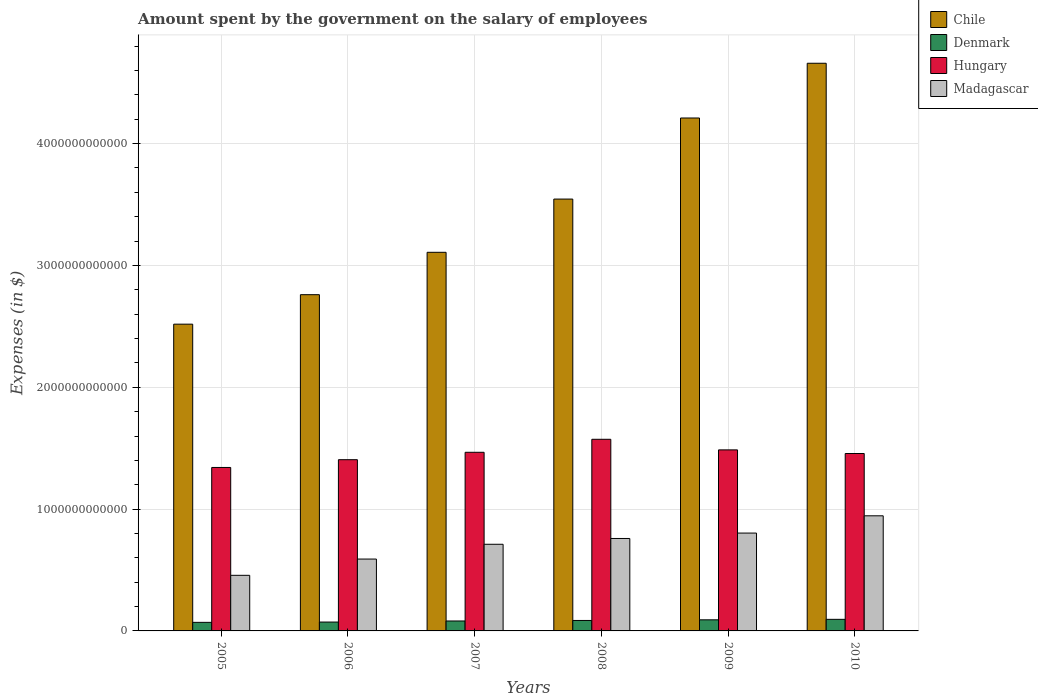How many groups of bars are there?
Give a very brief answer. 6. Are the number of bars per tick equal to the number of legend labels?
Give a very brief answer. Yes. Are the number of bars on each tick of the X-axis equal?
Provide a succinct answer. Yes. What is the label of the 1st group of bars from the left?
Your answer should be very brief. 2005. What is the amount spent on the salary of employees by the government in Denmark in 2006?
Your response must be concise. 7.28e+1. Across all years, what is the maximum amount spent on the salary of employees by the government in Madagascar?
Your answer should be compact. 9.45e+11. Across all years, what is the minimum amount spent on the salary of employees by the government in Hungary?
Provide a succinct answer. 1.34e+12. In which year was the amount spent on the salary of employees by the government in Chile maximum?
Offer a terse response. 2010. What is the total amount spent on the salary of employees by the government in Chile in the graph?
Provide a short and direct response. 2.08e+13. What is the difference between the amount spent on the salary of employees by the government in Chile in 2006 and that in 2007?
Make the answer very short. -3.48e+11. What is the difference between the amount spent on the salary of employees by the government in Denmark in 2007 and the amount spent on the salary of employees by the government in Madagascar in 2009?
Ensure brevity in your answer.  -7.22e+11. What is the average amount spent on the salary of employees by the government in Chile per year?
Provide a succinct answer. 3.47e+12. In the year 2007, what is the difference between the amount spent on the salary of employees by the government in Madagascar and amount spent on the salary of employees by the government in Chile?
Give a very brief answer. -2.40e+12. In how many years, is the amount spent on the salary of employees by the government in Madagascar greater than 4200000000000 $?
Your answer should be compact. 0. What is the ratio of the amount spent on the salary of employees by the government in Madagascar in 2005 to that in 2007?
Make the answer very short. 0.64. Is the amount spent on the salary of employees by the government in Denmark in 2005 less than that in 2008?
Your answer should be compact. Yes. Is the difference between the amount spent on the salary of employees by the government in Madagascar in 2005 and 2006 greater than the difference between the amount spent on the salary of employees by the government in Chile in 2005 and 2006?
Provide a short and direct response. Yes. What is the difference between the highest and the second highest amount spent on the salary of employees by the government in Denmark?
Offer a terse response. 4.02e+09. What is the difference between the highest and the lowest amount spent on the salary of employees by the government in Madagascar?
Your answer should be very brief. 4.89e+11. In how many years, is the amount spent on the salary of employees by the government in Denmark greater than the average amount spent on the salary of employees by the government in Denmark taken over all years?
Give a very brief answer. 3. Is it the case that in every year, the sum of the amount spent on the salary of employees by the government in Madagascar and amount spent on the salary of employees by the government in Hungary is greater than the sum of amount spent on the salary of employees by the government in Denmark and amount spent on the salary of employees by the government in Chile?
Your answer should be very brief. No. What does the 4th bar from the left in 2006 represents?
Provide a short and direct response. Madagascar. How many years are there in the graph?
Offer a terse response. 6. What is the difference between two consecutive major ticks on the Y-axis?
Your answer should be compact. 1.00e+12. Are the values on the major ticks of Y-axis written in scientific E-notation?
Offer a terse response. No. Does the graph contain grids?
Your response must be concise. Yes. Where does the legend appear in the graph?
Your response must be concise. Top right. What is the title of the graph?
Your answer should be compact. Amount spent by the government on the salary of employees. What is the label or title of the Y-axis?
Make the answer very short. Expenses (in $). What is the Expenses (in $) in Chile in 2005?
Offer a very short reply. 2.52e+12. What is the Expenses (in $) of Denmark in 2005?
Provide a short and direct response. 7.03e+1. What is the Expenses (in $) in Hungary in 2005?
Your answer should be very brief. 1.34e+12. What is the Expenses (in $) of Madagascar in 2005?
Make the answer very short. 4.56e+11. What is the Expenses (in $) of Chile in 2006?
Ensure brevity in your answer.  2.76e+12. What is the Expenses (in $) of Denmark in 2006?
Offer a terse response. 7.28e+1. What is the Expenses (in $) of Hungary in 2006?
Give a very brief answer. 1.41e+12. What is the Expenses (in $) in Madagascar in 2006?
Ensure brevity in your answer.  5.90e+11. What is the Expenses (in $) of Chile in 2007?
Offer a very short reply. 3.11e+12. What is the Expenses (in $) of Denmark in 2007?
Keep it short and to the point. 8.16e+1. What is the Expenses (in $) in Hungary in 2007?
Ensure brevity in your answer.  1.47e+12. What is the Expenses (in $) of Madagascar in 2007?
Provide a succinct answer. 7.11e+11. What is the Expenses (in $) of Chile in 2008?
Provide a short and direct response. 3.54e+12. What is the Expenses (in $) in Denmark in 2008?
Ensure brevity in your answer.  8.58e+1. What is the Expenses (in $) in Hungary in 2008?
Your response must be concise. 1.57e+12. What is the Expenses (in $) in Madagascar in 2008?
Your answer should be very brief. 7.59e+11. What is the Expenses (in $) in Chile in 2009?
Offer a very short reply. 4.21e+12. What is the Expenses (in $) in Denmark in 2009?
Offer a terse response. 9.11e+1. What is the Expenses (in $) in Hungary in 2009?
Your answer should be very brief. 1.49e+12. What is the Expenses (in $) in Madagascar in 2009?
Your answer should be very brief. 8.03e+11. What is the Expenses (in $) of Chile in 2010?
Your response must be concise. 4.66e+12. What is the Expenses (in $) in Denmark in 2010?
Your response must be concise. 9.51e+1. What is the Expenses (in $) of Hungary in 2010?
Offer a very short reply. 1.46e+12. What is the Expenses (in $) in Madagascar in 2010?
Make the answer very short. 9.45e+11. Across all years, what is the maximum Expenses (in $) of Chile?
Your answer should be compact. 4.66e+12. Across all years, what is the maximum Expenses (in $) in Denmark?
Keep it short and to the point. 9.51e+1. Across all years, what is the maximum Expenses (in $) in Hungary?
Provide a succinct answer. 1.57e+12. Across all years, what is the maximum Expenses (in $) of Madagascar?
Your answer should be very brief. 9.45e+11. Across all years, what is the minimum Expenses (in $) of Chile?
Your answer should be compact. 2.52e+12. Across all years, what is the minimum Expenses (in $) in Denmark?
Offer a very short reply. 7.03e+1. Across all years, what is the minimum Expenses (in $) of Hungary?
Provide a succinct answer. 1.34e+12. Across all years, what is the minimum Expenses (in $) of Madagascar?
Offer a very short reply. 4.56e+11. What is the total Expenses (in $) in Chile in the graph?
Provide a short and direct response. 2.08e+13. What is the total Expenses (in $) of Denmark in the graph?
Make the answer very short. 4.97e+11. What is the total Expenses (in $) of Hungary in the graph?
Provide a short and direct response. 8.73e+12. What is the total Expenses (in $) of Madagascar in the graph?
Your answer should be very brief. 4.26e+12. What is the difference between the Expenses (in $) in Chile in 2005 and that in 2006?
Offer a terse response. -2.42e+11. What is the difference between the Expenses (in $) in Denmark in 2005 and that in 2006?
Provide a succinct answer. -2.54e+09. What is the difference between the Expenses (in $) of Hungary in 2005 and that in 2006?
Your response must be concise. -6.37e+1. What is the difference between the Expenses (in $) of Madagascar in 2005 and that in 2006?
Provide a succinct answer. -1.34e+11. What is the difference between the Expenses (in $) of Chile in 2005 and that in 2007?
Give a very brief answer. -5.90e+11. What is the difference between the Expenses (in $) in Denmark in 2005 and that in 2007?
Offer a very short reply. -1.13e+1. What is the difference between the Expenses (in $) in Hungary in 2005 and that in 2007?
Keep it short and to the point. -1.25e+11. What is the difference between the Expenses (in $) in Madagascar in 2005 and that in 2007?
Give a very brief answer. -2.55e+11. What is the difference between the Expenses (in $) in Chile in 2005 and that in 2008?
Your answer should be very brief. -1.03e+12. What is the difference between the Expenses (in $) in Denmark in 2005 and that in 2008?
Give a very brief answer. -1.55e+1. What is the difference between the Expenses (in $) in Hungary in 2005 and that in 2008?
Your answer should be compact. -2.31e+11. What is the difference between the Expenses (in $) of Madagascar in 2005 and that in 2008?
Your answer should be very brief. -3.02e+11. What is the difference between the Expenses (in $) of Chile in 2005 and that in 2009?
Offer a terse response. -1.69e+12. What is the difference between the Expenses (in $) in Denmark in 2005 and that in 2009?
Your answer should be compact. -2.08e+1. What is the difference between the Expenses (in $) in Hungary in 2005 and that in 2009?
Your answer should be very brief. -1.44e+11. What is the difference between the Expenses (in $) in Madagascar in 2005 and that in 2009?
Ensure brevity in your answer.  -3.47e+11. What is the difference between the Expenses (in $) in Chile in 2005 and that in 2010?
Your answer should be compact. -2.14e+12. What is the difference between the Expenses (in $) in Denmark in 2005 and that in 2010?
Keep it short and to the point. -2.48e+1. What is the difference between the Expenses (in $) of Hungary in 2005 and that in 2010?
Your answer should be compact. -1.15e+11. What is the difference between the Expenses (in $) of Madagascar in 2005 and that in 2010?
Give a very brief answer. -4.89e+11. What is the difference between the Expenses (in $) in Chile in 2006 and that in 2007?
Provide a short and direct response. -3.48e+11. What is the difference between the Expenses (in $) of Denmark in 2006 and that in 2007?
Give a very brief answer. -8.81e+09. What is the difference between the Expenses (in $) of Hungary in 2006 and that in 2007?
Ensure brevity in your answer.  -6.08e+1. What is the difference between the Expenses (in $) of Madagascar in 2006 and that in 2007?
Provide a succinct answer. -1.21e+11. What is the difference between the Expenses (in $) of Chile in 2006 and that in 2008?
Your response must be concise. -7.85e+11. What is the difference between the Expenses (in $) in Denmark in 2006 and that in 2008?
Provide a succinct answer. -1.30e+1. What is the difference between the Expenses (in $) of Hungary in 2006 and that in 2008?
Provide a short and direct response. -1.68e+11. What is the difference between the Expenses (in $) in Madagascar in 2006 and that in 2008?
Provide a succinct answer. -1.69e+11. What is the difference between the Expenses (in $) of Chile in 2006 and that in 2009?
Ensure brevity in your answer.  -1.45e+12. What is the difference between the Expenses (in $) of Denmark in 2006 and that in 2009?
Keep it short and to the point. -1.83e+1. What is the difference between the Expenses (in $) in Hungary in 2006 and that in 2009?
Your answer should be very brief. -8.06e+1. What is the difference between the Expenses (in $) of Madagascar in 2006 and that in 2009?
Your answer should be very brief. -2.13e+11. What is the difference between the Expenses (in $) in Chile in 2006 and that in 2010?
Ensure brevity in your answer.  -1.90e+12. What is the difference between the Expenses (in $) of Denmark in 2006 and that in 2010?
Offer a very short reply. -2.23e+1. What is the difference between the Expenses (in $) of Hungary in 2006 and that in 2010?
Give a very brief answer. -5.09e+1. What is the difference between the Expenses (in $) in Madagascar in 2006 and that in 2010?
Offer a terse response. -3.55e+11. What is the difference between the Expenses (in $) in Chile in 2007 and that in 2008?
Give a very brief answer. -4.37e+11. What is the difference between the Expenses (in $) in Denmark in 2007 and that in 2008?
Offer a terse response. -4.16e+09. What is the difference between the Expenses (in $) in Hungary in 2007 and that in 2008?
Keep it short and to the point. -1.07e+11. What is the difference between the Expenses (in $) in Madagascar in 2007 and that in 2008?
Provide a succinct answer. -4.77e+1. What is the difference between the Expenses (in $) in Chile in 2007 and that in 2009?
Your answer should be very brief. -1.10e+12. What is the difference between the Expenses (in $) in Denmark in 2007 and that in 2009?
Offer a very short reply. -9.48e+09. What is the difference between the Expenses (in $) in Hungary in 2007 and that in 2009?
Offer a terse response. -1.98e+1. What is the difference between the Expenses (in $) of Madagascar in 2007 and that in 2009?
Provide a short and direct response. -9.20e+1. What is the difference between the Expenses (in $) in Chile in 2007 and that in 2010?
Provide a succinct answer. -1.55e+12. What is the difference between the Expenses (in $) in Denmark in 2007 and that in 2010?
Ensure brevity in your answer.  -1.35e+1. What is the difference between the Expenses (in $) in Hungary in 2007 and that in 2010?
Ensure brevity in your answer.  9.96e+09. What is the difference between the Expenses (in $) in Madagascar in 2007 and that in 2010?
Ensure brevity in your answer.  -2.34e+11. What is the difference between the Expenses (in $) of Chile in 2008 and that in 2009?
Your response must be concise. -6.66e+11. What is the difference between the Expenses (in $) of Denmark in 2008 and that in 2009?
Your answer should be compact. -5.31e+09. What is the difference between the Expenses (in $) of Hungary in 2008 and that in 2009?
Your answer should be compact. 8.70e+1. What is the difference between the Expenses (in $) in Madagascar in 2008 and that in 2009?
Keep it short and to the point. -4.43e+1. What is the difference between the Expenses (in $) in Chile in 2008 and that in 2010?
Offer a very short reply. -1.11e+12. What is the difference between the Expenses (in $) in Denmark in 2008 and that in 2010?
Your answer should be very brief. -9.33e+09. What is the difference between the Expenses (in $) in Hungary in 2008 and that in 2010?
Make the answer very short. 1.17e+11. What is the difference between the Expenses (in $) of Madagascar in 2008 and that in 2010?
Offer a terse response. -1.86e+11. What is the difference between the Expenses (in $) of Chile in 2009 and that in 2010?
Your answer should be compact. -4.49e+11. What is the difference between the Expenses (in $) of Denmark in 2009 and that in 2010?
Keep it short and to the point. -4.02e+09. What is the difference between the Expenses (in $) in Hungary in 2009 and that in 2010?
Your response must be concise. 2.97e+1. What is the difference between the Expenses (in $) in Madagascar in 2009 and that in 2010?
Make the answer very short. -1.42e+11. What is the difference between the Expenses (in $) in Chile in 2005 and the Expenses (in $) in Denmark in 2006?
Keep it short and to the point. 2.45e+12. What is the difference between the Expenses (in $) in Chile in 2005 and the Expenses (in $) in Hungary in 2006?
Provide a short and direct response. 1.11e+12. What is the difference between the Expenses (in $) of Chile in 2005 and the Expenses (in $) of Madagascar in 2006?
Your answer should be compact. 1.93e+12. What is the difference between the Expenses (in $) in Denmark in 2005 and the Expenses (in $) in Hungary in 2006?
Give a very brief answer. -1.34e+12. What is the difference between the Expenses (in $) in Denmark in 2005 and the Expenses (in $) in Madagascar in 2006?
Keep it short and to the point. -5.20e+11. What is the difference between the Expenses (in $) in Hungary in 2005 and the Expenses (in $) in Madagascar in 2006?
Make the answer very short. 7.52e+11. What is the difference between the Expenses (in $) in Chile in 2005 and the Expenses (in $) in Denmark in 2007?
Your answer should be compact. 2.44e+12. What is the difference between the Expenses (in $) of Chile in 2005 and the Expenses (in $) of Hungary in 2007?
Provide a succinct answer. 1.05e+12. What is the difference between the Expenses (in $) of Chile in 2005 and the Expenses (in $) of Madagascar in 2007?
Offer a very short reply. 1.81e+12. What is the difference between the Expenses (in $) in Denmark in 2005 and the Expenses (in $) in Hungary in 2007?
Your answer should be compact. -1.40e+12. What is the difference between the Expenses (in $) in Denmark in 2005 and the Expenses (in $) in Madagascar in 2007?
Ensure brevity in your answer.  -6.41e+11. What is the difference between the Expenses (in $) of Hungary in 2005 and the Expenses (in $) of Madagascar in 2007?
Your answer should be very brief. 6.31e+11. What is the difference between the Expenses (in $) of Chile in 2005 and the Expenses (in $) of Denmark in 2008?
Provide a succinct answer. 2.43e+12. What is the difference between the Expenses (in $) in Chile in 2005 and the Expenses (in $) in Hungary in 2008?
Your response must be concise. 9.45e+11. What is the difference between the Expenses (in $) in Chile in 2005 and the Expenses (in $) in Madagascar in 2008?
Your response must be concise. 1.76e+12. What is the difference between the Expenses (in $) in Denmark in 2005 and the Expenses (in $) in Hungary in 2008?
Provide a succinct answer. -1.50e+12. What is the difference between the Expenses (in $) in Denmark in 2005 and the Expenses (in $) in Madagascar in 2008?
Provide a short and direct response. -6.89e+11. What is the difference between the Expenses (in $) in Hungary in 2005 and the Expenses (in $) in Madagascar in 2008?
Offer a very short reply. 5.83e+11. What is the difference between the Expenses (in $) in Chile in 2005 and the Expenses (in $) in Denmark in 2009?
Provide a short and direct response. 2.43e+12. What is the difference between the Expenses (in $) of Chile in 2005 and the Expenses (in $) of Hungary in 2009?
Offer a terse response. 1.03e+12. What is the difference between the Expenses (in $) in Chile in 2005 and the Expenses (in $) in Madagascar in 2009?
Ensure brevity in your answer.  1.71e+12. What is the difference between the Expenses (in $) of Denmark in 2005 and the Expenses (in $) of Hungary in 2009?
Ensure brevity in your answer.  -1.42e+12. What is the difference between the Expenses (in $) of Denmark in 2005 and the Expenses (in $) of Madagascar in 2009?
Your answer should be compact. -7.33e+11. What is the difference between the Expenses (in $) in Hungary in 2005 and the Expenses (in $) in Madagascar in 2009?
Provide a short and direct response. 5.39e+11. What is the difference between the Expenses (in $) in Chile in 2005 and the Expenses (in $) in Denmark in 2010?
Keep it short and to the point. 2.42e+12. What is the difference between the Expenses (in $) of Chile in 2005 and the Expenses (in $) of Hungary in 2010?
Provide a short and direct response. 1.06e+12. What is the difference between the Expenses (in $) of Chile in 2005 and the Expenses (in $) of Madagascar in 2010?
Provide a succinct answer. 1.57e+12. What is the difference between the Expenses (in $) in Denmark in 2005 and the Expenses (in $) in Hungary in 2010?
Your answer should be very brief. -1.39e+12. What is the difference between the Expenses (in $) in Denmark in 2005 and the Expenses (in $) in Madagascar in 2010?
Provide a succinct answer. -8.75e+11. What is the difference between the Expenses (in $) in Hungary in 2005 and the Expenses (in $) in Madagascar in 2010?
Your answer should be very brief. 3.97e+11. What is the difference between the Expenses (in $) of Chile in 2006 and the Expenses (in $) of Denmark in 2007?
Your answer should be compact. 2.68e+12. What is the difference between the Expenses (in $) in Chile in 2006 and the Expenses (in $) in Hungary in 2007?
Your answer should be very brief. 1.29e+12. What is the difference between the Expenses (in $) of Chile in 2006 and the Expenses (in $) of Madagascar in 2007?
Your response must be concise. 2.05e+12. What is the difference between the Expenses (in $) of Denmark in 2006 and the Expenses (in $) of Hungary in 2007?
Give a very brief answer. -1.39e+12. What is the difference between the Expenses (in $) in Denmark in 2006 and the Expenses (in $) in Madagascar in 2007?
Your answer should be compact. -6.38e+11. What is the difference between the Expenses (in $) in Hungary in 2006 and the Expenses (in $) in Madagascar in 2007?
Your answer should be compact. 6.94e+11. What is the difference between the Expenses (in $) in Chile in 2006 and the Expenses (in $) in Denmark in 2008?
Offer a very short reply. 2.67e+12. What is the difference between the Expenses (in $) of Chile in 2006 and the Expenses (in $) of Hungary in 2008?
Make the answer very short. 1.19e+12. What is the difference between the Expenses (in $) in Chile in 2006 and the Expenses (in $) in Madagascar in 2008?
Give a very brief answer. 2.00e+12. What is the difference between the Expenses (in $) in Denmark in 2006 and the Expenses (in $) in Hungary in 2008?
Give a very brief answer. -1.50e+12. What is the difference between the Expenses (in $) in Denmark in 2006 and the Expenses (in $) in Madagascar in 2008?
Offer a terse response. -6.86e+11. What is the difference between the Expenses (in $) of Hungary in 2006 and the Expenses (in $) of Madagascar in 2008?
Your answer should be compact. 6.47e+11. What is the difference between the Expenses (in $) of Chile in 2006 and the Expenses (in $) of Denmark in 2009?
Offer a very short reply. 2.67e+12. What is the difference between the Expenses (in $) in Chile in 2006 and the Expenses (in $) in Hungary in 2009?
Offer a terse response. 1.27e+12. What is the difference between the Expenses (in $) in Chile in 2006 and the Expenses (in $) in Madagascar in 2009?
Offer a terse response. 1.96e+12. What is the difference between the Expenses (in $) of Denmark in 2006 and the Expenses (in $) of Hungary in 2009?
Provide a short and direct response. -1.41e+12. What is the difference between the Expenses (in $) of Denmark in 2006 and the Expenses (in $) of Madagascar in 2009?
Your answer should be compact. -7.30e+11. What is the difference between the Expenses (in $) of Hungary in 2006 and the Expenses (in $) of Madagascar in 2009?
Your response must be concise. 6.02e+11. What is the difference between the Expenses (in $) of Chile in 2006 and the Expenses (in $) of Denmark in 2010?
Give a very brief answer. 2.66e+12. What is the difference between the Expenses (in $) of Chile in 2006 and the Expenses (in $) of Hungary in 2010?
Ensure brevity in your answer.  1.30e+12. What is the difference between the Expenses (in $) in Chile in 2006 and the Expenses (in $) in Madagascar in 2010?
Your answer should be very brief. 1.82e+12. What is the difference between the Expenses (in $) of Denmark in 2006 and the Expenses (in $) of Hungary in 2010?
Provide a short and direct response. -1.38e+12. What is the difference between the Expenses (in $) in Denmark in 2006 and the Expenses (in $) in Madagascar in 2010?
Your answer should be compact. -8.72e+11. What is the difference between the Expenses (in $) of Hungary in 2006 and the Expenses (in $) of Madagascar in 2010?
Ensure brevity in your answer.  4.61e+11. What is the difference between the Expenses (in $) of Chile in 2007 and the Expenses (in $) of Denmark in 2008?
Your response must be concise. 3.02e+12. What is the difference between the Expenses (in $) in Chile in 2007 and the Expenses (in $) in Hungary in 2008?
Ensure brevity in your answer.  1.53e+12. What is the difference between the Expenses (in $) of Chile in 2007 and the Expenses (in $) of Madagascar in 2008?
Provide a succinct answer. 2.35e+12. What is the difference between the Expenses (in $) in Denmark in 2007 and the Expenses (in $) in Hungary in 2008?
Your answer should be very brief. -1.49e+12. What is the difference between the Expenses (in $) of Denmark in 2007 and the Expenses (in $) of Madagascar in 2008?
Provide a succinct answer. -6.77e+11. What is the difference between the Expenses (in $) of Hungary in 2007 and the Expenses (in $) of Madagascar in 2008?
Keep it short and to the point. 7.07e+11. What is the difference between the Expenses (in $) of Chile in 2007 and the Expenses (in $) of Denmark in 2009?
Provide a succinct answer. 3.02e+12. What is the difference between the Expenses (in $) in Chile in 2007 and the Expenses (in $) in Hungary in 2009?
Ensure brevity in your answer.  1.62e+12. What is the difference between the Expenses (in $) in Chile in 2007 and the Expenses (in $) in Madagascar in 2009?
Keep it short and to the point. 2.30e+12. What is the difference between the Expenses (in $) of Denmark in 2007 and the Expenses (in $) of Hungary in 2009?
Your answer should be compact. -1.40e+12. What is the difference between the Expenses (in $) of Denmark in 2007 and the Expenses (in $) of Madagascar in 2009?
Provide a short and direct response. -7.22e+11. What is the difference between the Expenses (in $) of Hungary in 2007 and the Expenses (in $) of Madagascar in 2009?
Ensure brevity in your answer.  6.63e+11. What is the difference between the Expenses (in $) of Chile in 2007 and the Expenses (in $) of Denmark in 2010?
Give a very brief answer. 3.01e+12. What is the difference between the Expenses (in $) of Chile in 2007 and the Expenses (in $) of Hungary in 2010?
Your answer should be very brief. 1.65e+12. What is the difference between the Expenses (in $) of Chile in 2007 and the Expenses (in $) of Madagascar in 2010?
Offer a terse response. 2.16e+12. What is the difference between the Expenses (in $) in Denmark in 2007 and the Expenses (in $) in Hungary in 2010?
Offer a very short reply. -1.37e+12. What is the difference between the Expenses (in $) in Denmark in 2007 and the Expenses (in $) in Madagascar in 2010?
Ensure brevity in your answer.  -8.63e+11. What is the difference between the Expenses (in $) of Hungary in 2007 and the Expenses (in $) of Madagascar in 2010?
Ensure brevity in your answer.  5.21e+11. What is the difference between the Expenses (in $) in Chile in 2008 and the Expenses (in $) in Denmark in 2009?
Offer a very short reply. 3.45e+12. What is the difference between the Expenses (in $) in Chile in 2008 and the Expenses (in $) in Hungary in 2009?
Your answer should be compact. 2.06e+12. What is the difference between the Expenses (in $) in Chile in 2008 and the Expenses (in $) in Madagascar in 2009?
Your response must be concise. 2.74e+12. What is the difference between the Expenses (in $) of Denmark in 2008 and the Expenses (in $) of Hungary in 2009?
Make the answer very short. -1.40e+12. What is the difference between the Expenses (in $) of Denmark in 2008 and the Expenses (in $) of Madagascar in 2009?
Give a very brief answer. -7.17e+11. What is the difference between the Expenses (in $) of Hungary in 2008 and the Expenses (in $) of Madagascar in 2009?
Make the answer very short. 7.70e+11. What is the difference between the Expenses (in $) in Chile in 2008 and the Expenses (in $) in Denmark in 2010?
Make the answer very short. 3.45e+12. What is the difference between the Expenses (in $) in Chile in 2008 and the Expenses (in $) in Hungary in 2010?
Provide a succinct answer. 2.09e+12. What is the difference between the Expenses (in $) in Chile in 2008 and the Expenses (in $) in Madagascar in 2010?
Offer a very short reply. 2.60e+12. What is the difference between the Expenses (in $) in Denmark in 2008 and the Expenses (in $) in Hungary in 2010?
Keep it short and to the point. -1.37e+12. What is the difference between the Expenses (in $) in Denmark in 2008 and the Expenses (in $) in Madagascar in 2010?
Your answer should be very brief. -8.59e+11. What is the difference between the Expenses (in $) of Hungary in 2008 and the Expenses (in $) of Madagascar in 2010?
Your answer should be very brief. 6.28e+11. What is the difference between the Expenses (in $) in Chile in 2009 and the Expenses (in $) in Denmark in 2010?
Give a very brief answer. 4.12e+12. What is the difference between the Expenses (in $) in Chile in 2009 and the Expenses (in $) in Hungary in 2010?
Your response must be concise. 2.75e+12. What is the difference between the Expenses (in $) in Chile in 2009 and the Expenses (in $) in Madagascar in 2010?
Offer a terse response. 3.27e+12. What is the difference between the Expenses (in $) of Denmark in 2009 and the Expenses (in $) of Hungary in 2010?
Offer a very short reply. -1.37e+12. What is the difference between the Expenses (in $) of Denmark in 2009 and the Expenses (in $) of Madagascar in 2010?
Your answer should be very brief. -8.54e+11. What is the difference between the Expenses (in $) of Hungary in 2009 and the Expenses (in $) of Madagascar in 2010?
Make the answer very short. 5.41e+11. What is the average Expenses (in $) of Chile per year?
Provide a succinct answer. 3.47e+12. What is the average Expenses (in $) of Denmark per year?
Provide a succinct answer. 8.28e+1. What is the average Expenses (in $) of Hungary per year?
Your response must be concise. 1.45e+12. What is the average Expenses (in $) of Madagascar per year?
Offer a terse response. 7.11e+11. In the year 2005, what is the difference between the Expenses (in $) of Chile and Expenses (in $) of Denmark?
Provide a short and direct response. 2.45e+12. In the year 2005, what is the difference between the Expenses (in $) of Chile and Expenses (in $) of Hungary?
Offer a terse response. 1.18e+12. In the year 2005, what is the difference between the Expenses (in $) in Chile and Expenses (in $) in Madagascar?
Provide a short and direct response. 2.06e+12. In the year 2005, what is the difference between the Expenses (in $) in Denmark and Expenses (in $) in Hungary?
Make the answer very short. -1.27e+12. In the year 2005, what is the difference between the Expenses (in $) of Denmark and Expenses (in $) of Madagascar?
Make the answer very short. -3.86e+11. In the year 2005, what is the difference between the Expenses (in $) of Hungary and Expenses (in $) of Madagascar?
Your response must be concise. 8.85e+11. In the year 2006, what is the difference between the Expenses (in $) of Chile and Expenses (in $) of Denmark?
Provide a short and direct response. 2.69e+12. In the year 2006, what is the difference between the Expenses (in $) of Chile and Expenses (in $) of Hungary?
Keep it short and to the point. 1.35e+12. In the year 2006, what is the difference between the Expenses (in $) of Chile and Expenses (in $) of Madagascar?
Provide a short and direct response. 2.17e+12. In the year 2006, what is the difference between the Expenses (in $) of Denmark and Expenses (in $) of Hungary?
Offer a very short reply. -1.33e+12. In the year 2006, what is the difference between the Expenses (in $) of Denmark and Expenses (in $) of Madagascar?
Provide a succinct answer. -5.17e+11. In the year 2006, what is the difference between the Expenses (in $) of Hungary and Expenses (in $) of Madagascar?
Your answer should be compact. 8.16e+11. In the year 2007, what is the difference between the Expenses (in $) of Chile and Expenses (in $) of Denmark?
Your answer should be very brief. 3.03e+12. In the year 2007, what is the difference between the Expenses (in $) of Chile and Expenses (in $) of Hungary?
Your answer should be very brief. 1.64e+12. In the year 2007, what is the difference between the Expenses (in $) of Chile and Expenses (in $) of Madagascar?
Offer a terse response. 2.40e+12. In the year 2007, what is the difference between the Expenses (in $) in Denmark and Expenses (in $) in Hungary?
Provide a succinct answer. -1.38e+12. In the year 2007, what is the difference between the Expenses (in $) of Denmark and Expenses (in $) of Madagascar?
Keep it short and to the point. -6.30e+11. In the year 2007, what is the difference between the Expenses (in $) in Hungary and Expenses (in $) in Madagascar?
Your response must be concise. 7.55e+11. In the year 2008, what is the difference between the Expenses (in $) of Chile and Expenses (in $) of Denmark?
Keep it short and to the point. 3.46e+12. In the year 2008, what is the difference between the Expenses (in $) in Chile and Expenses (in $) in Hungary?
Offer a very short reply. 1.97e+12. In the year 2008, what is the difference between the Expenses (in $) in Chile and Expenses (in $) in Madagascar?
Make the answer very short. 2.79e+12. In the year 2008, what is the difference between the Expenses (in $) in Denmark and Expenses (in $) in Hungary?
Keep it short and to the point. -1.49e+12. In the year 2008, what is the difference between the Expenses (in $) in Denmark and Expenses (in $) in Madagascar?
Offer a terse response. -6.73e+11. In the year 2008, what is the difference between the Expenses (in $) of Hungary and Expenses (in $) of Madagascar?
Offer a very short reply. 8.14e+11. In the year 2009, what is the difference between the Expenses (in $) in Chile and Expenses (in $) in Denmark?
Your answer should be very brief. 4.12e+12. In the year 2009, what is the difference between the Expenses (in $) in Chile and Expenses (in $) in Hungary?
Give a very brief answer. 2.72e+12. In the year 2009, what is the difference between the Expenses (in $) of Chile and Expenses (in $) of Madagascar?
Your answer should be very brief. 3.41e+12. In the year 2009, what is the difference between the Expenses (in $) of Denmark and Expenses (in $) of Hungary?
Provide a succinct answer. -1.39e+12. In the year 2009, what is the difference between the Expenses (in $) of Denmark and Expenses (in $) of Madagascar?
Provide a succinct answer. -7.12e+11. In the year 2009, what is the difference between the Expenses (in $) in Hungary and Expenses (in $) in Madagascar?
Your response must be concise. 6.83e+11. In the year 2010, what is the difference between the Expenses (in $) of Chile and Expenses (in $) of Denmark?
Keep it short and to the point. 4.56e+12. In the year 2010, what is the difference between the Expenses (in $) in Chile and Expenses (in $) in Hungary?
Ensure brevity in your answer.  3.20e+12. In the year 2010, what is the difference between the Expenses (in $) in Chile and Expenses (in $) in Madagascar?
Your answer should be compact. 3.71e+12. In the year 2010, what is the difference between the Expenses (in $) in Denmark and Expenses (in $) in Hungary?
Your response must be concise. -1.36e+12. In the year 2010, what is the difference between the Expenses (in $) of Denmark and Expenses (in $) of Madagascar?
Make the answer very short. -8.50e+11. In the year 2010, what is the difference between the Expenses (in $) of Hungary and Expenses (in $) of Madagascar?
Keep it short and to the point. 5.11e+11. What is the ratio of the Expenses (in $) of Chile in 2005 to that in 2006?
Your response must be concise. 0.91. What is the ratio of the Expenses (in $) in Denmark in 2005 to that in 2006?
Offer a very short reply. 0.97. What is the ratio of the Expenses (in $) in Hungary in 2005 to that in 2006?
Provide a succinct answer. 0.95. What is the ratio of the Expenses (in $) in Madagascar in 2005 to that in 2006?
Offer a very short reply. 0.77. What is the ratio of the Expenses (in $) of Chile in 2005 to that in 2007?
Offer a terse response. 0.81. What is the ratio of the Expenses (in $) of Denmark in 2005 to that in 2007?
Provide a short and direct response. 0.86. What is the ratio of the Expenses (in $) of Hungary in 2005 to that in 2007?
Keep it short and to the point. 0.92. What is the ratio of the Expenses (in $) in Madagascar in 2005 to that in 2007?
Give a very brief answer. 0.64. What is the ratio of the Expenses (in $) in Chile in 2005 to that in 2008?
Your response must be concise. 0.71. What is the ratio of the Expenses (in $) in Denmark in 2005 to that in 2008?
Your answer should be compact. 0.82. What is the ratio of the Expenses (in $) in Hungary in 2005 to that in 2008?
Ensure brevity in your answer.  0.85. What is the ratio of the Expenses (in $) in Madagascar in 2005 to that in 2008?
Your answer should be very brief. 0.6. What is the ratio of the Expenses (in $) of Chile in 2005 to that in 2009?
Give a very brief answer. 0.6. What is the ratio of the Expenses (in $) in Denmark in 2005 to that in 2009?
Provide a short and direct response. 0.77. What is the ratio of the Expenses (in $) of Hungary in 2005 to that in 2009?
Give a very brief answer. 0.9. What is the ratio of the Expenses (in $) in Madagascar in 2005 to that in 2009?
Offer a terse response. 0.57. What is the ratio of the Expenses (in $) of Chile in 2005 to that in 2010?
Your response must be concise. 0.54. What is the ratio of the Expenses (in $) in Denmark in 2005 to that in 2010?
Keep it short and to the point. 0.74. What is the ratio of the Expenses (in $) in Hungary in 2005 to that in 2010?
Provide a succinct answer. 0.92. What is the ratio of the Expenses (in $) of Madagascar in 2005 to that in 2010?
Provide a short and direct response. 0.48. What is the ratio of the Expenses (in $) of Chile in 2006 to that in 2007?
Give a very brief answer. 0.89. What is the ratio of the Expenses (in $) in Denmark in 2006 to that in 2007?
Provide a short and direct response. 0.89. What is the ratio of the Expenses (in $) of Hungary in 2006 to that in 2007?
Make the answer very short. 0.96. What is the ratio of the Expenses (in $) of Madagascar in 2006 to that in 2007?
Your response must be concise. 0.83. What is the ratio of the Expenses (in $) of Chile in 2006 to that in 2008?
Give a very brief answer. 0.78. What is the ratio of the Expenses (in $) in Denmark in 2006 to that in 2008?
Your response must be concise. 0.85. What is the ratio of the Expenses (in $) of Hungary in 2006 to that in 2008?
Provide a short and direct response. 0.89. What is the ratio of the Expenses (in $) of Madagascar in 2006 to that in 2008?
Provide a short and direct response. 0.78. What is the ratio of the Expenses (in $) in Chile in 2006 to that in 2009?
Your answer should be very brief. 0.66. What is the ratio of the Expenses (in $) in Denmark in 2006 to that in 2009?
Keep it short and to the point. 0.8. What is the ratio of the Expenses (in $) of Hungary in 2006 to that in 2009?
Make the answer very short. 0.95. What is the ratio of the Expenses (in $) of Madagascar in 2006 to that in 2009?
Make the answer very short. 0.73. What is the ratio of the Expenses (in $) of Chile in 2006 to that in 2010?
Keep it short and to the point. 0.59. What is the ratio of the Expenses (in $) of Denmark in 2006 to that in 2010?
Your answer should be very brief. 0.77. What is the ratio of the Expenses (in $) in Hungary in 2006 to that in 2010?
Provide a succinct answer. 0.97. What is the ratio of the Expenses (in $) of Madagascar in 2006 to that in 2010?
Offer a very short reply. 0.62. What is the ratio of the Expenses (in $) of Chile in 2007 to that in 2008?
Give a very brief answer. 0.88. What is the ratio of the Expenses (in $) of Denmark in 2007 to that in 2008?
Make the answer very short. 0.95. What is the ratio of the Expenses (in $) of Hungary in 2007 to that in 2008?
Ensure brevity in your answer.  0.93. What is the ratio of the Expenses (in $) in Madagascar in 2007 to that in 2008?
Provide a short and direct response. 0.94. What is the ratio of the Expenses (in $) of Chile in 2007 to that in 2009?
Make the answer very short. 0.74. What is the ratio of the Expenses (in $) in Denmark in 2007 to that in 2009?
Provide a short and direct response. 0.9. What is the ratio of the Expenses (in $) in Hungary in 2007 to that in 2009?
Offer a very short reply. 0.99. What is the ratio of the Expenses (in $) of Madagascar in 2007 to that in 2009?
Your answer should be compact. 0.89. What is the ratio of the Expenses (in $) in Chile in 2007 to that in 2010?
Ensure brevity in your answer.  0.67. What is the ratio of the Expenses (in $) in Denmark in 2007 to that in 2010?
Keep it short and to the point. 0.86. What is the ratio of the Expenses (in $) in Hungary in 2007 to that in 2010?
Provide a succinct answer. 1.01. What is the ratio of the Expenses (in $) of Madagascar in 2007 to that in 2010?
Make the answer very short. 0.75. What is the ratio of the Expenses (in $) in Chile in 2008 to that in 2009?
Provide a succinct answer. 0.84. What is the ratio of the Expenses (in $) of Denmark in 2008 to that in 2009?
Ensure brevity in your answer.  0.94. What is the ratio of the Expenses (in $) in Hungary in 2008 to that in 2009?
Your response must be concise. 1.06. What is the ratio of the Expenses (in $) of Madagascar in 2008 to that in 2009?
Your response must be concise. 0.94. What is the ratio of the Expenses (in $) of Chile in 2008 to that in 2010?
Provide a succinct answer. 0.76. What is the ratio of the Expenses (in $) of Denmark in 2008 to that in 2010?
Keep it short and to the point. 0.9. What is the ratio of the Expenses (in $) in Hungary in 2008 to that in 2010?
Your response must be concise. 1.08. What is the ratio of the Expenses (in $) in Madagascar in 2008 to that in 2010?
Ensure brevity in your answer.  0.8. What is the ratio of the Expenses (in $) in Chile in 2009 to that in 2010?
Make the answer very short. 0.9. What is the ratio of the Expenses (in $) of Denmark in 2009 to that in 2010?
Your response must be concise. 0.96. What is the ratio of the Expenses (in $) of Hungary in 2009 to that in 2010?
Your answer should be very brief. 1.02. What is the ratio of the Expenses (in $) in Madagascar in 2009 to that in 2010?
Give a very brief answer. 0.85. What is the difference between the highest and the second highest Expenses (in $) of Chile?
Offer a terse response. 4.49e+11. What is the difference between the highest and the second highest Expenses (in $) of Denmark?
Provide a short and direct response. 4.02e+09. What is the difference between the highest and the second highest Expenses (in $) of Hungary?
Your response must be concise. 8.70e+1. What is the difference between the highest and the second highest Expenses (in $) of Madagascar?
Provide a succinct answer. 1.42e+11. What is the difference between the highest and the lowest Expenses (in $) in Chile?
Provide a succinct answer. 2.14e+12. What is the difference between the highest and the lowest Expenses (in $) of Denmark?
Ensure brevity in your answer.  2.48e+1. What is the difference between the highest and the lowest Expenses (in $) in Hungary?
Make the answer very short. 2.31e+11. What is the difference between the highest and the lowest Expenses (in $) of Madagascar?
Provide a succinct answer. 4.89e+11. 